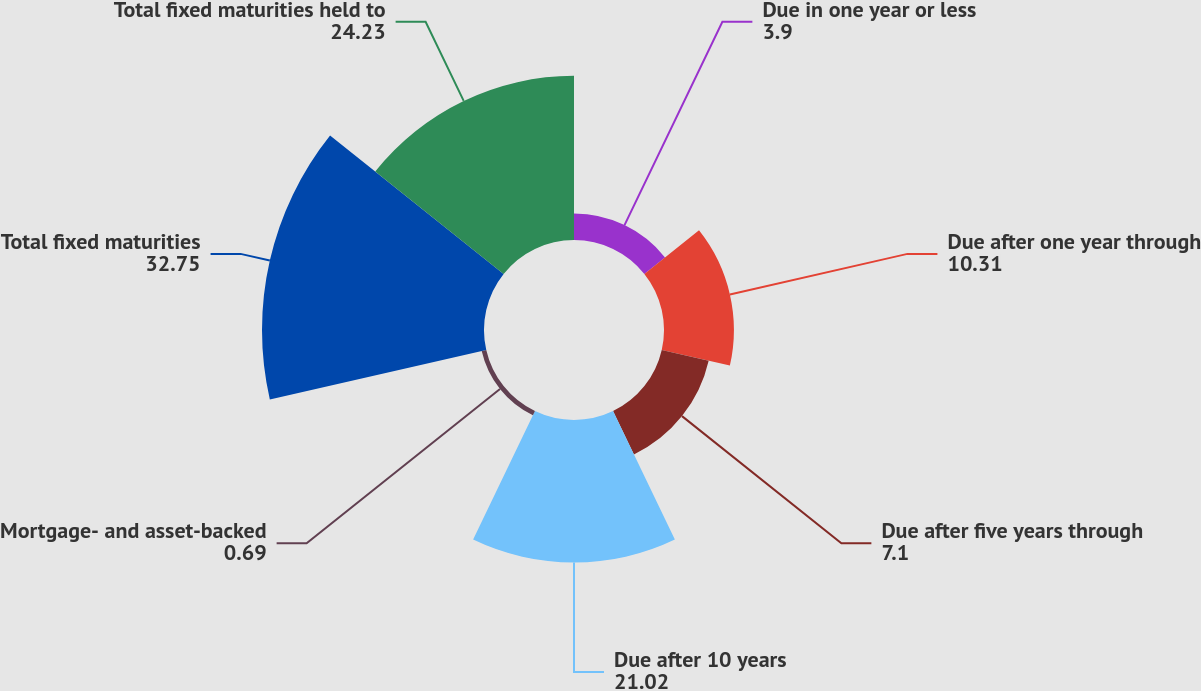<chart> <loc_0><loc_0><loc_500><loc_500><pie_chart><fcel>Due in one year or less<fcel>Due after one year through<fcel>Due after five years through<fcel>Due after 10 years<fcel>Mortgage- and asset-backed<fcel>Total fixed maturities<fcel>Total fixed maturities held to<nl><fcel>3.9%<fcel>10.31%<fcel>7.1%<fcel>21.02%<fcel>0.69%<fcel>32.75%<fcel>24.23%<nl></chart> 